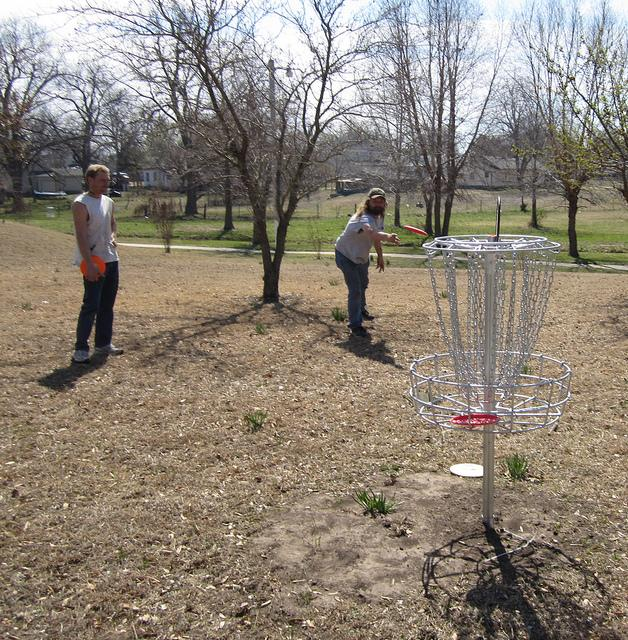What sport are the two men playing?

Choices:
A) soccer
B) disc golf
C) basketball
D) baseball disc golf 